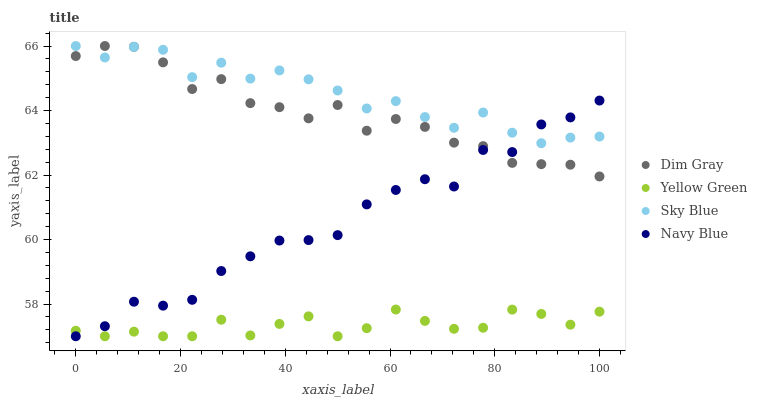Does Yellow Green have the minimum area under the curve?
Answer yes or no. Yes. Does Sky Blue have the maximum area under the curve?
Answer yes or no. Yes. Does Dim Gray have the minimum area under the curve?
Answer yes or no. No. Does Dim Gray have the maximum area under the curve?
Answer yes or no. No. Is Yellow Green the smoothest?
Answer yes or no. Yes. Is Sky Blue the roughest?
Answer yes or no. Yes. Is Dim Gray the smoothest?
Answer yes or no. No. Is Dim Gray the roughest?
Answer yes or no. No. Does Yellow Green have the lowest value?
Answer yes or no. Yes. Does Dim Gray have the lowest value?
Answer yes or no. No. Does Dim Gray have the highest value?
Answer yes or no. Yes. Does Yellow Green have the highest value?
Answer yes or no. No. Is Yellow Green less than Sky Blue?
Answer yes or no. Yes. Is Dim Gray greater than Yellow Green?
Answer yes or no. Yes. Does Sky Blue intersect Navy Blue?
Answer yes or no. Yes. Is Sky Blue less than Navy Blue?
Answer yes or no. No. Is Sky Blue greater than Navy Blue?
Answer yes or no. No. Does Yellow Green intersect Sky Blue?
Answer yes or no. No. 